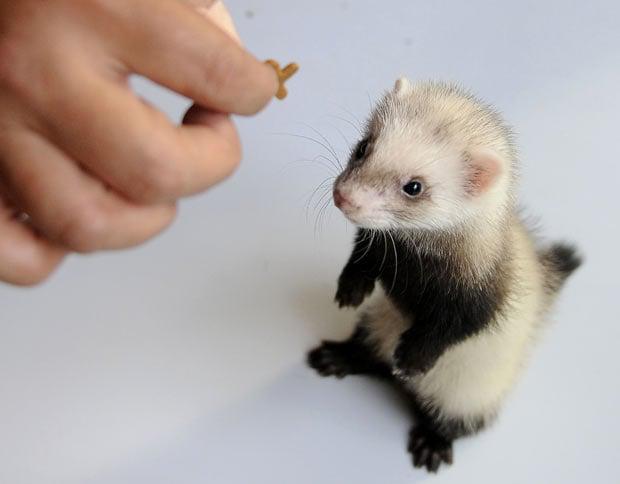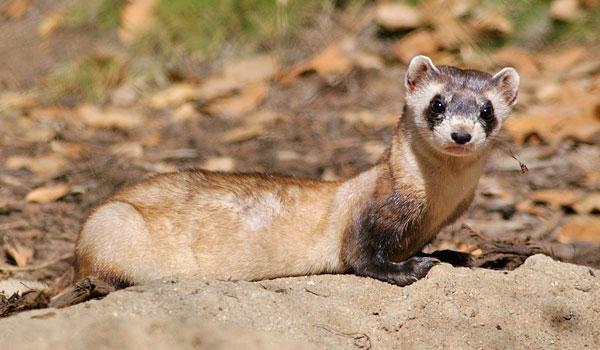The first image is the image on the left, the second image is the image on the right. Analyze the images presented: Is the assertion "There is only one weasel coming out of a hole in one of the pictures." valid? Answer yes or no. No. The first image is the image on the left, the second image is the image on the right. For the images shown, is this caption "At least one photograph shows exactly one animal with light brown, rather than black, markings around its eyes." true? Answer yes or no. Yes. 